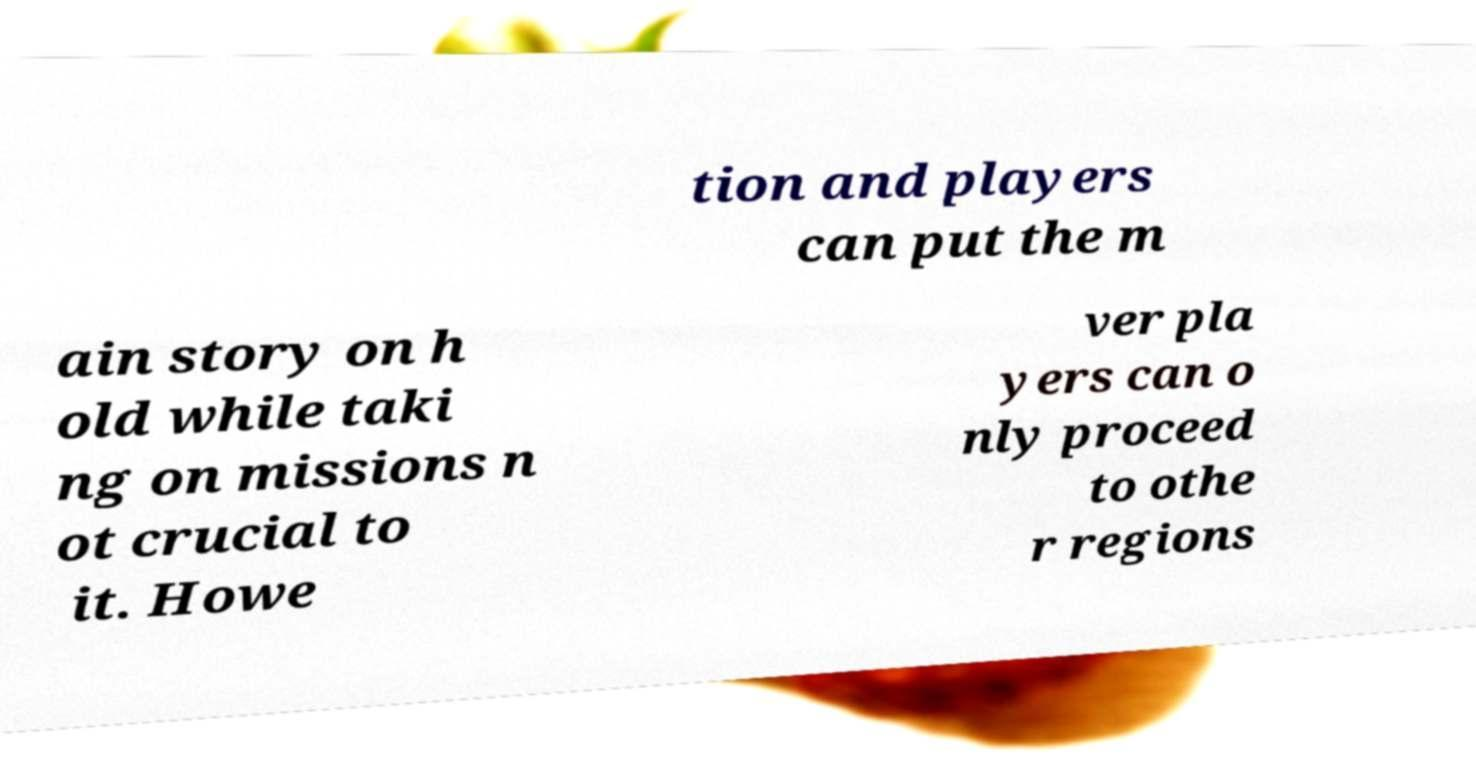Could you extract and type out the text from this image? tion and players can put the m ain story on h old while taki ng on missions n ot crucial to it. Howe ver pla yers can o nly proceed to othe r regions 